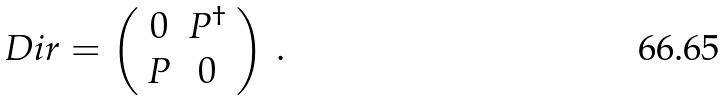<formula> <loc_0><loc_0><loc_500><loc_500>\ D i r = \left ( \begin{array} { c c } 0 & P ^ { \dag } \\ P & 0 \end{array} \right ) \, .</formula> 